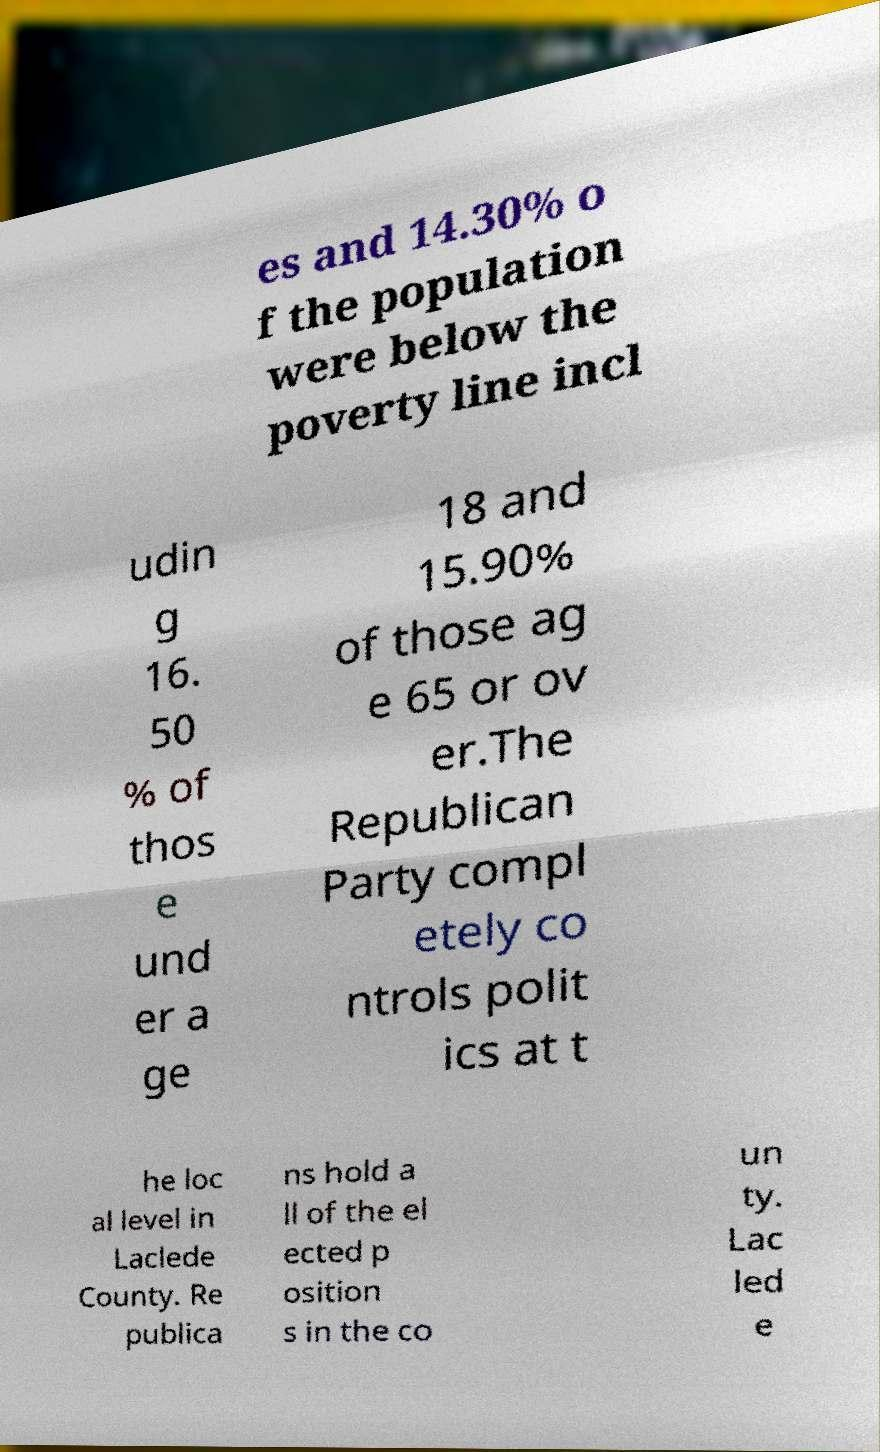Can you read and provide the text displayed in the image?This photo seems to have some interesting text. Can you extract and type it out for me? es and 14.30% o f the population were below the poverty line incl udin g 16. 50 % of thos e und er a ge 18 and 15.90% of those ag e 65 or ov er.The Republican Party compl etely co ntrols polit ics at t he loc al level in Laclede County. Re publica ns hold a ll of the el ected p osition s in the co un ty. Lac led e 